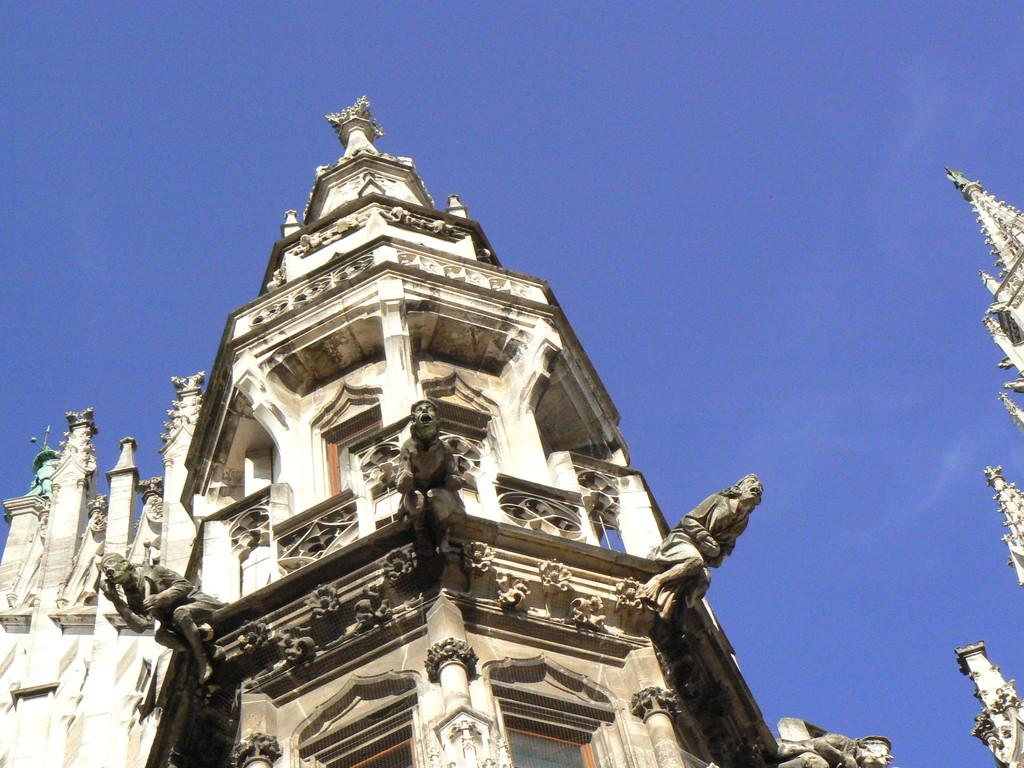What structure is located at the bottom of the image? There is a building at the bottom of the image. What decorative elements can be seen on the walls of the building? There are statues on the walls of the building. What is visible at the top of the image? The sky is visible at the top of the image. What is the tendency of the ants in the image? There are no ants present in the image. How many cushions are visible in the image? There are no cushions present in the image. 